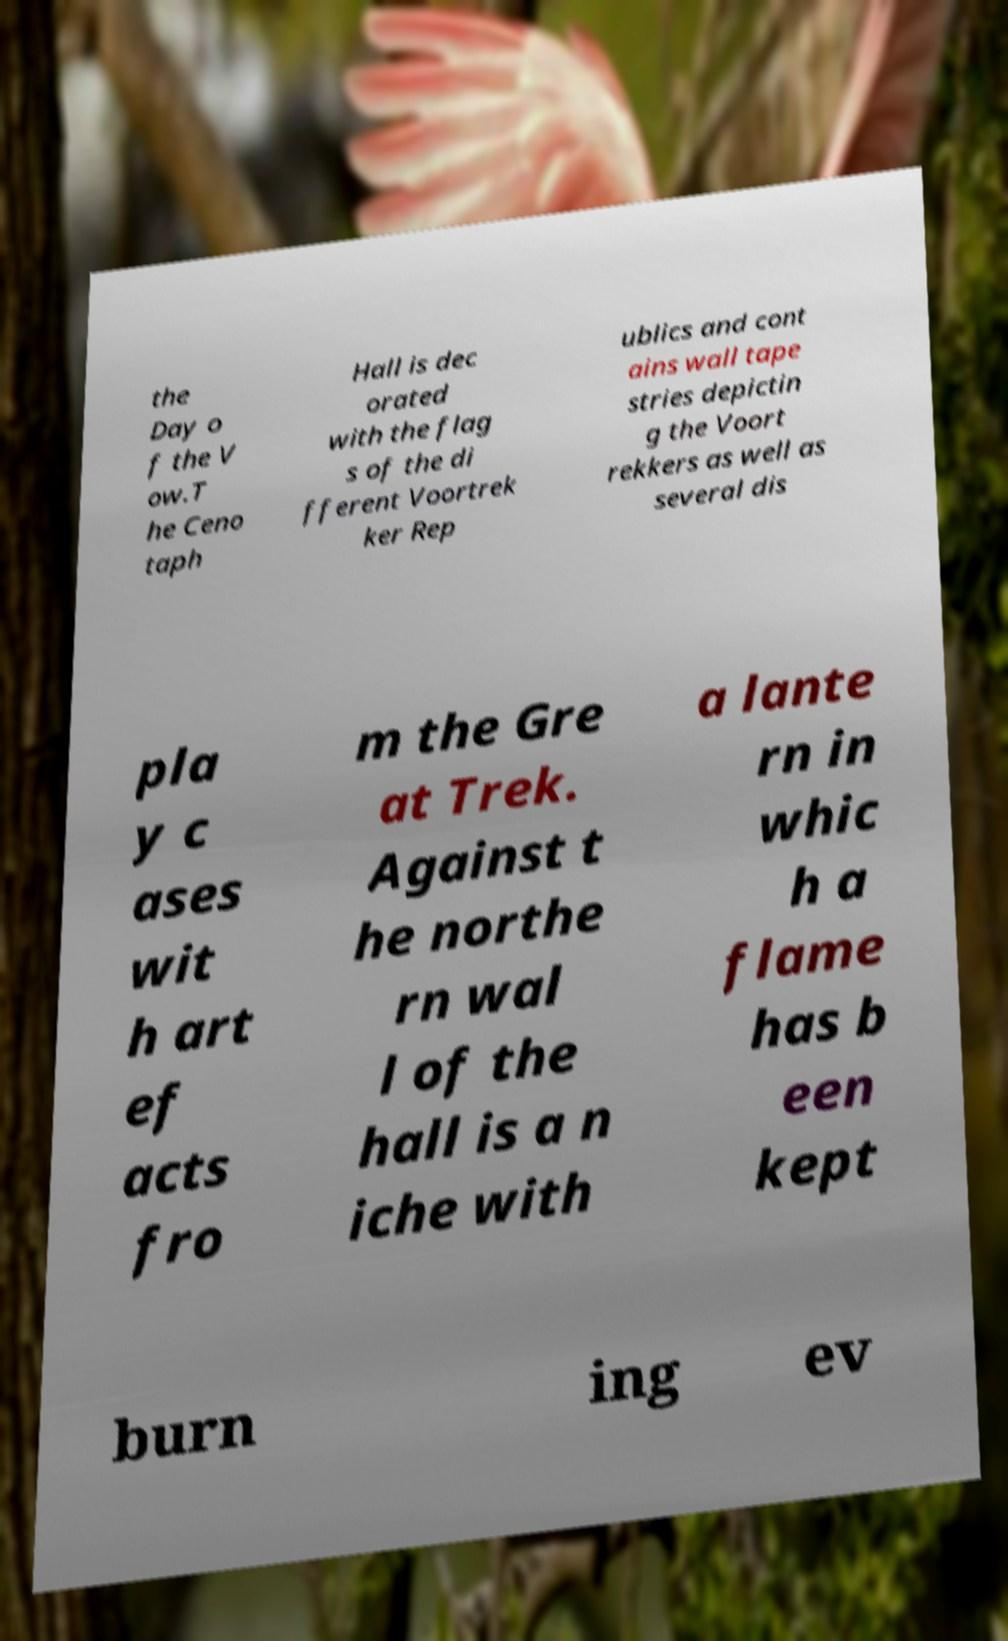Can you accurately transcribe the text from the provided image for me? the Day o f the V ow.T he Ceno taph Hall is dec orated with the flag s of the di fferent Voortrek ker Rep ublics and cont ains wall tape stries depictin g the Voort rekkers as well as several dis pla y c ases wit h art ef acts fro m the Gre at Trek. Against t he northe rn wal l of the hall is a n iche with a lante rn in whic h a flame has b een kept burn ing ev 